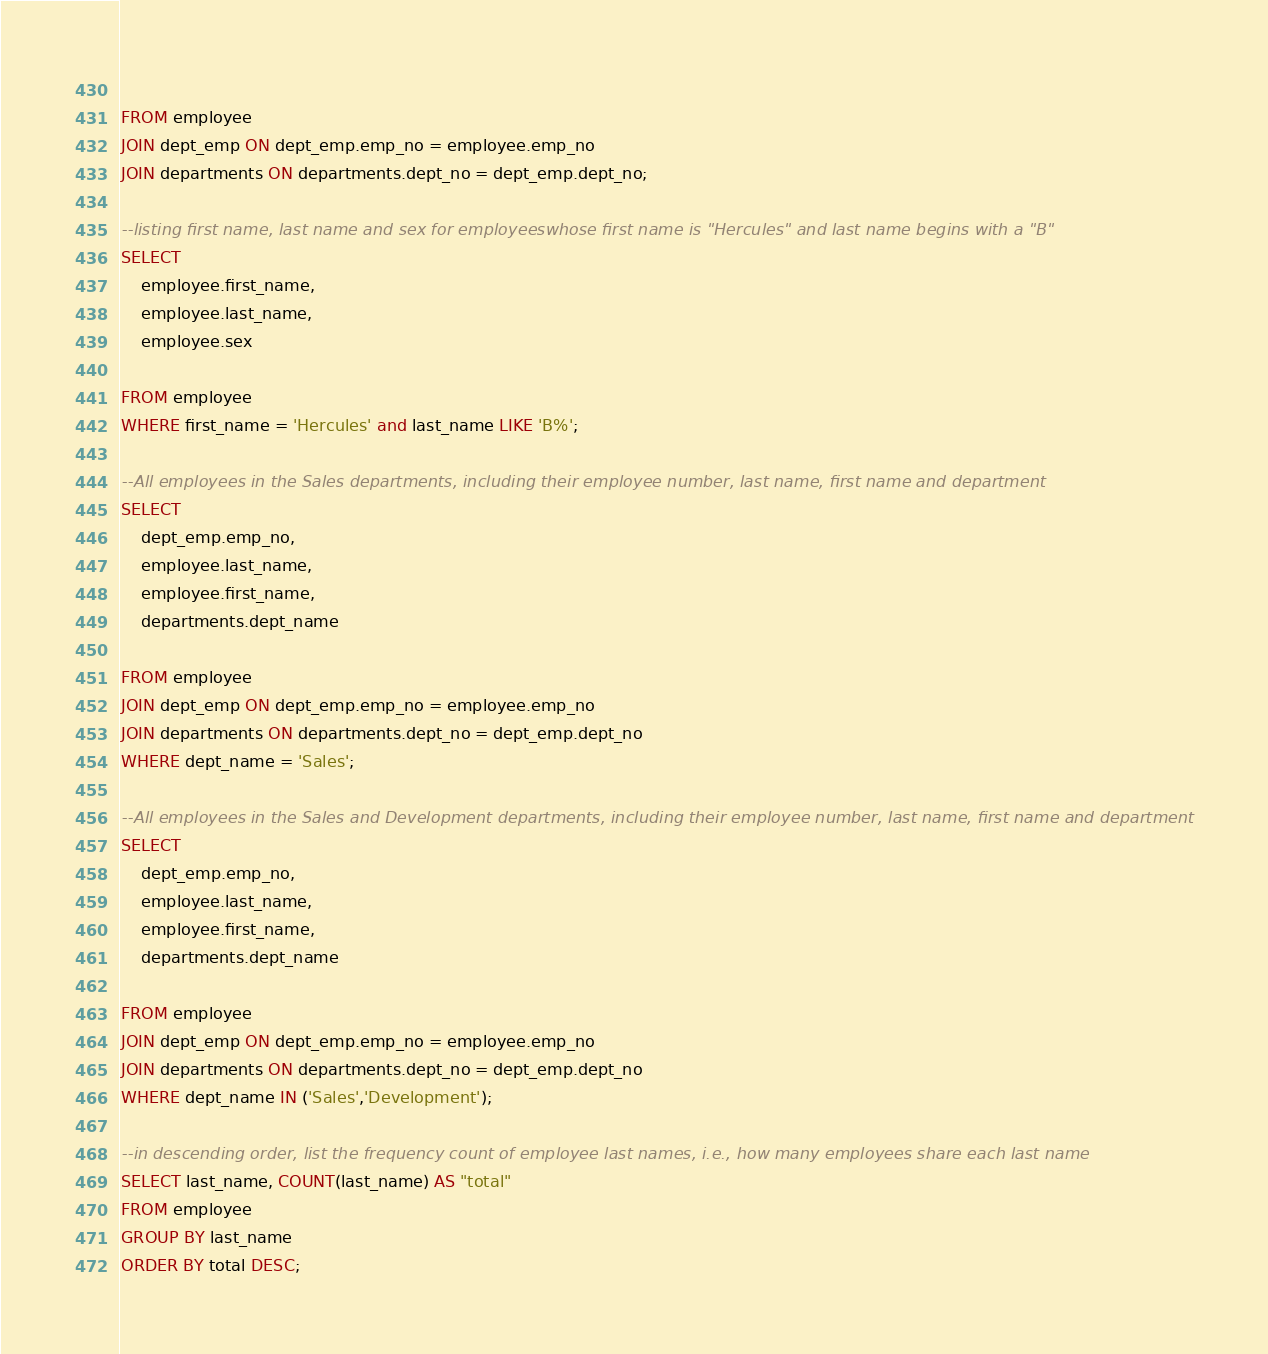<code> <loc_0><loc_0><loc_500><loc_500><_SQL_>	
FROM employee
JOIN dept_emp ON dept_emp.emp_no = employee.emp_no
JOIN departments ON departments.dept_no = dept_emp.dept_no;

--listing first name, last name and sex for employeeswhose first name is "Hercules" and last name begins with a "B"
SELECT
	employee.first_name,
	employee.last_name,
	employee.sex
	
FROM employee 
WHERE first_name = 'Hercules' and last_name LIKE 'B%';

--All employees in the Sales departments, including their employee number, last name, first name and department
SELECT
	dept_emp.emp_no,
	employee.last_name,
	employee.first_name,
	departments.dept_name
	
FROM employee
JOIN dept_emp ON dept_emp.emp_no = employee.emp_no
JOIN departments ON departments.dept_no = dept_emp.dept_no
WHERE dept_name = 'Sales';

--All employees in the Sales and Development departments, including their employee number, last name, first name and department
SELECT
	dept_emp.emp_no,
	employee.last_name,
	employee.first_name,
	departments.dept_name

FROM employee
JOIN dept_emp ON dept_emp.emp_no = employee.emp_no
JOIN departments ON departments.dept_no = dept_emp.dept_no
WHERE dept_name IN ('Sales','Development');

--in descending order, list the frequency count of employee last names, i.e., how many employees share each last name
SELECT last_name, COUNT(last_name) AS "total" 
FROM employee
GROUP BY last_name
ORDER BY total DESC;</code> 